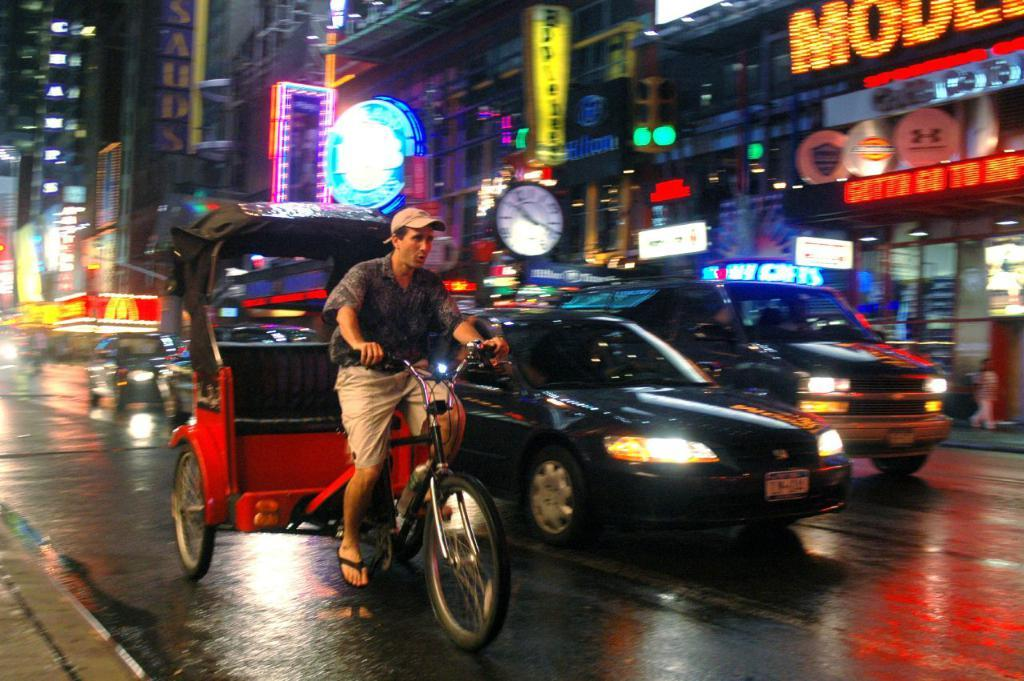Provide a one-sentence caption for the provided image. Cars and a pedi cab are on the street and they just passed McDonald's. 